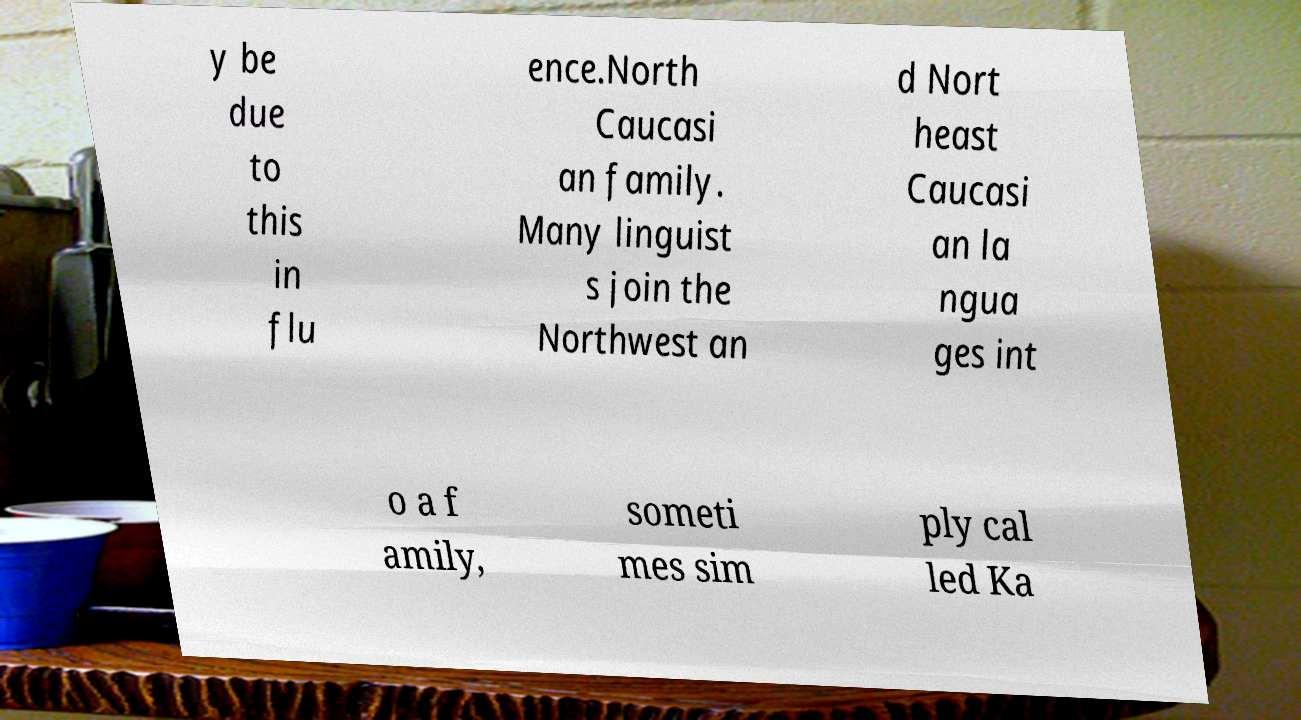For documentation purposes, I need the text within this image transcribed. Could you provide that? y be due to this in flu ence.North Caucasi an family. Many linguist s join the Northwest an d Nort heast Caucasi an la ngua ges int o a f amily, someti mes sim ply cal led Ka 